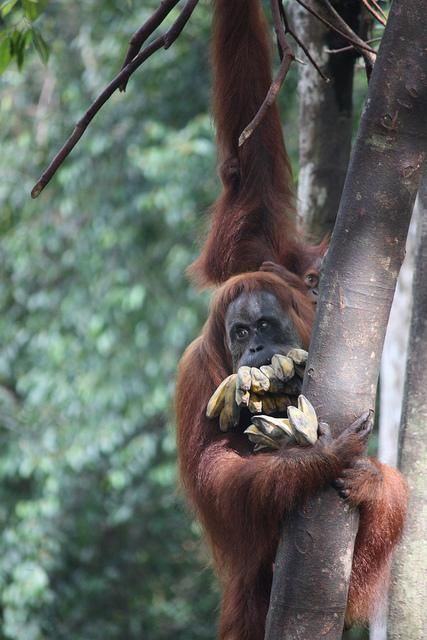What kind of fruit does the orangutan have in its mouth? bananas 